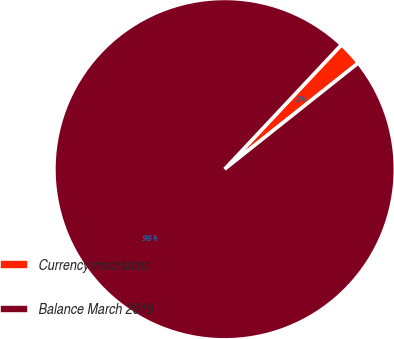Convert chart to OTSL. <chart><loc_0><loc_0><loc_500><loc_500><pie_chart><fcel>Currency translation<fcel>Balance March 2019<nl><fcel>2.32%<fcel>97.68%<nl></chart> 